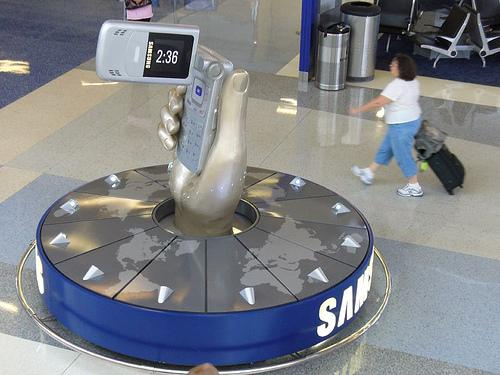What is the theme of the image, and provide some details from the image to support the theme. The theme is related to travel and technology, with an airport setting and a Samsung phone display. Detail the attire of the woman as illustrated in the image. The lady in the image is wearing blue pants, a short-sleeved white shirt, and white sneakers with blue stripes. Mention the key object in the image and its purpose. A Samsung cellular phone display is showcasing the phone with the time 236 on its screen. Mention an artistic element in the image and its composition. A gray world map is presented on a sundial with a blue and white design. Discuss the primary elements that indicate the location of the image. The image was taken in an airport, featuring silver and black seats, suitcases, and a woman pulling luggage. Describe the functional objects in the image, like seating and waste disposal. Silver and black seats are available for sitting, and a pair of silver trash cans is there for waste. Highlight the activity of the woman and the luggage she is using. The woman is pulling a black suitcase on wheels, and she is wearing blue pants with white sneakers. Identify the person and their activity in the image. A lady, wearing blue pants and white sneakers, is pulling a backpack on wheels. Describe the primary colors and their corresponding elements observed in the image. Blue is present on the carpet, the lady's pants, and the sneakers; gray and beige on the floor tiles. List two objects in the image that represent technology, and briefly describe them. Samsung cellular phone display, showing the time 236; A large fake hand holding the cell phone. 